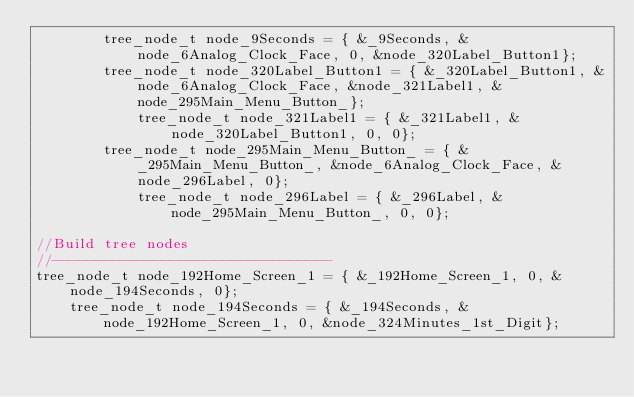<code> <loc_0><loc_0><loc_500><loc_500><_C_>        tree_node_t node_9Seconds = { &_9Seconds, &node_6Analog_Clock_Face, 0, &node_320Label_Button1};
        tree_node_t node_320Label_Button1 = { &_320Label_Button1, &node_6Analog_Clock_Face, &node_321Label1, &node_295Main_Menu_Button_};
            tree_node_t node_321Label1 = { &_321Label1, &node_320Label_Button1, 0, 0};
        tree_node_t node_295Main_Menu_Button_ = { &_295Main_Menu_Button_, &node_6Analog_Clock_Face, &node_296Label, 0};
            tree_node_t node_296Label = { &_296Label, &node_295Main_Menu_Button_, 0, 0};

//Build tree nodes
//---------------------------------
tree_node_t node_192Home_Screen_1 = { &_192Home_Screen_1, 0, &node_194Seconds, 0};
    tree_node_t node_194Seconds = { &_194Seconds, &node_192Home_Screen_1, 0, &node_324Minutes_1st_Digit};</code> 